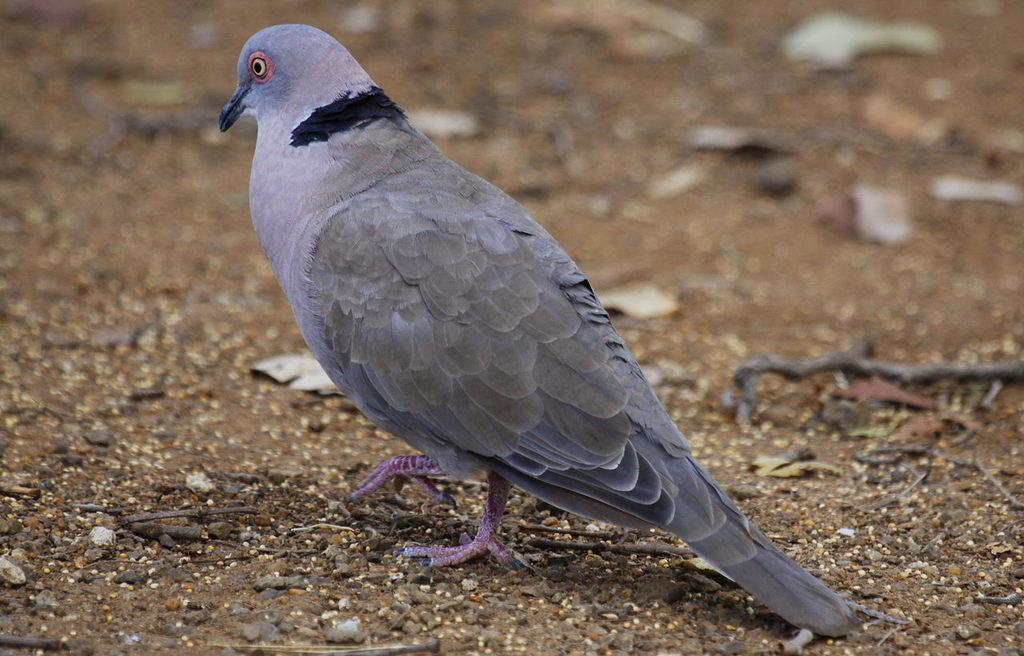What is the main subject in the center of the image? There is a bird in the center of the image. Where is the bird located? The bird is on the ground. What else can be seen in the image besides the bird? There are twigs in the image. What type of flag is visible in the image? There is no flag present in the image. What is the boundary of the town in the image? There is no town or boundary present in the image; it features a bird on the ground and some twigs. 